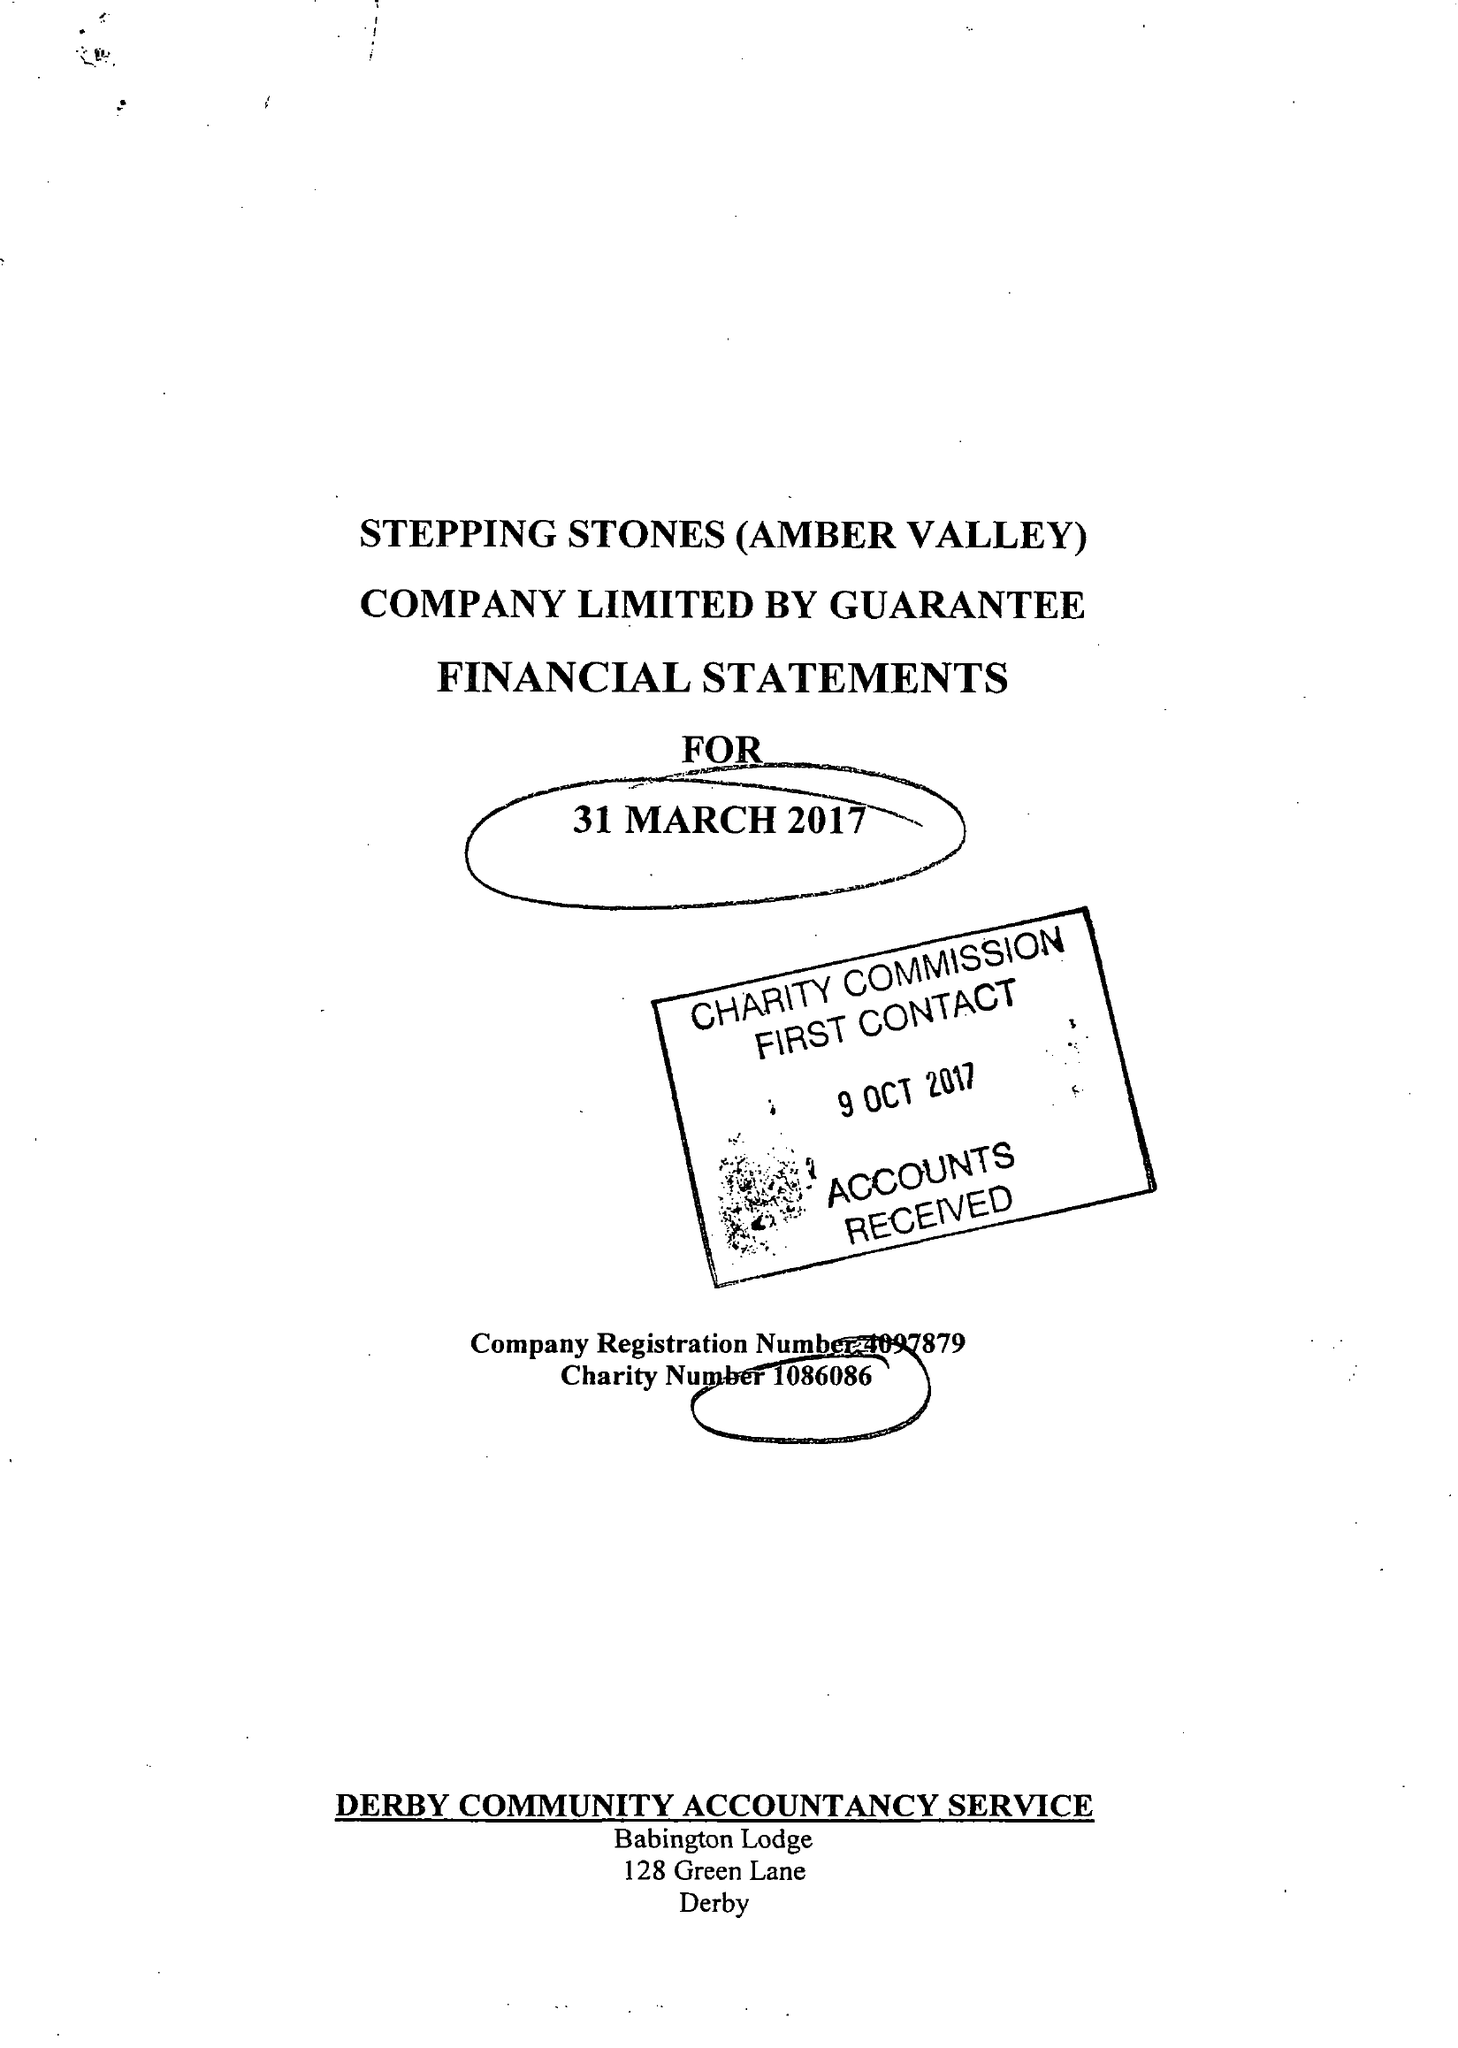What is the value for the spending_annually_in_british_pounds?
Answer the question using a single word or phrase. 126111.00 